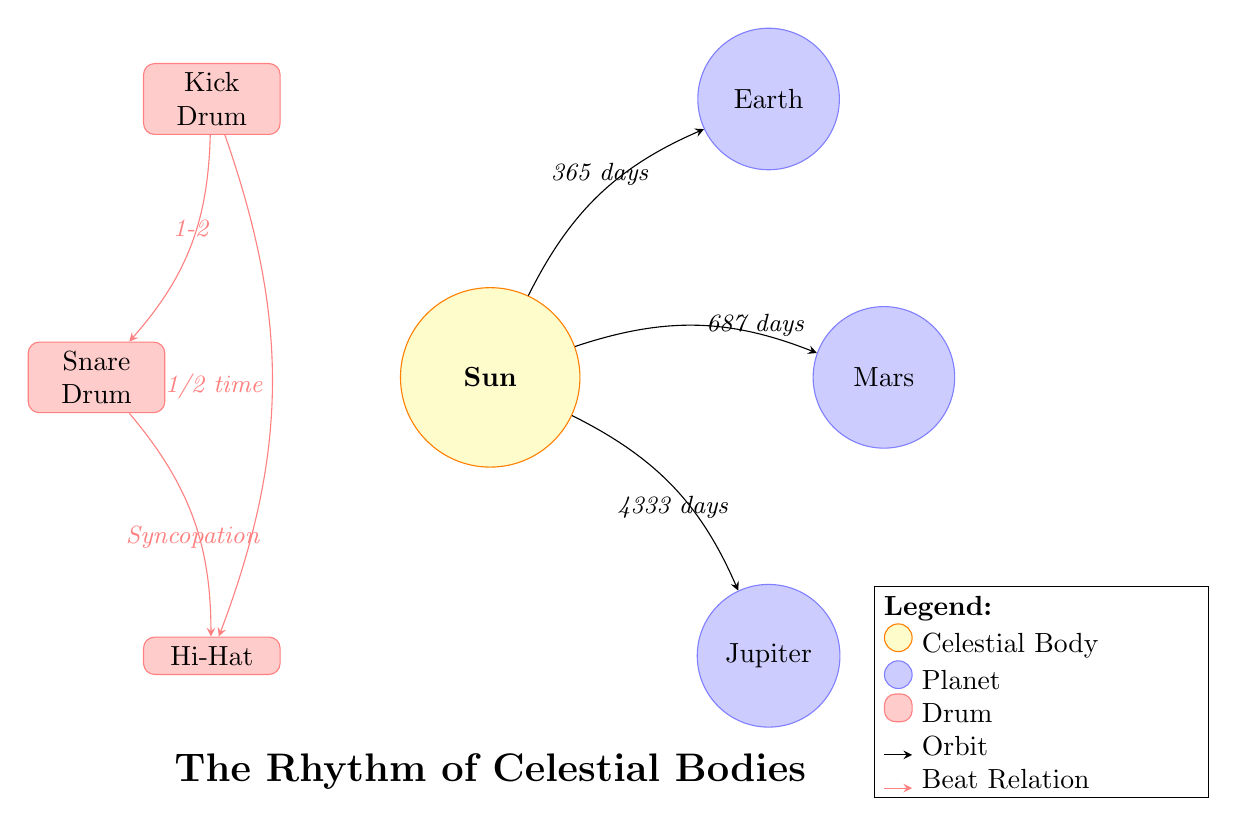What is the orbital period of Earth? The diagram shows that Earth has an orbital period of 365 days, indicated by the arrow pointing from the Sun to Earth labeled with this duration.
Answer: 365 days How many planets are represented in the diagram? The diagram visually presents three planets: Earth, Mars, and Jupiter. Counting the circles labeled as planets gives us a total of three.
Answer: 3 What is the relationship between the Kick Drum and the Snare Drum? The diagram indicates that there is a direct relationship labeled as "1-2" between the Kick Drum and the Snare Drum, which implies a specific timing or beat pattern.
Answer: 1-2 Which planetary body has the longest orbital period? Among the planets represented, Jupiter is shown to have the longest orbital period of 4333 days, as detailed in the arrow connecting it to the Sun.
Answer: 4333 days What type of diagram is represented? The structure and elements present—celestial bodies, planets, and drums—combined with their relationships and periods, classify this as an Astronomy Diagram.
Answer: Astronomy Diagram How does the Hi-Hat relate to the Snare Drum? The diagram demonstrates a connection between the Snare Drum and the Hi-Hat with the label "Syncopation," indicating a rhythmic relationship that enhances the beat pattern within the music context.
Answer: Syncopation Which planet has an orbital period of 687 days? The diagram lists Mars with an orbital period of 687 days, identified by the arrow leading from the Sun to Mars.
Answer: Mars What does the edge between the Kick Drum and the Hi-Hat represent? The edge labeled "1/2 time" denotes the relationship between the Kick Drum and the Hi-Hat, indicating that the Hi-Hat plays at half the time of the Kick Drum, contributing to the overall rhythm.
Answer: 1/2 time 